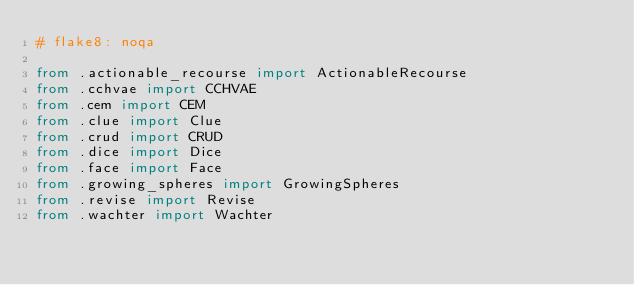<code> <loc_0><loc_0><loc_500><loc_500><_Python_># flake8: noqa

from .actionable_recourse import ActionableRecourse
from .cchvae import CCHVAE
from .cem import CEM
from .clue import Clue
from .crud import CRUD
from .dice import Dice
from .face import Face
from .growing_spheres import GrowingSpheres
from .revise import Revise
from .wachter import Wachter
</code> 